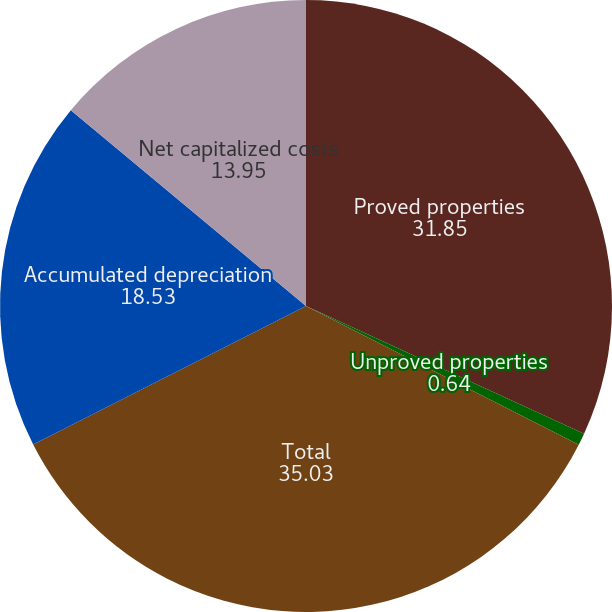<chart> <loc_0><loc_0><loc_500><loc_500><pie_chart><fcel>Proved properties<fcel>Unproved properties<fcel>Total<fcel>Accumulated depreciation<fcel>Net capitalized costs<nl><fcel>31.85%<fcel>0.64%<fcel>35.03%<fcel>18.53%<fcel>13.95%<nl></chart> 